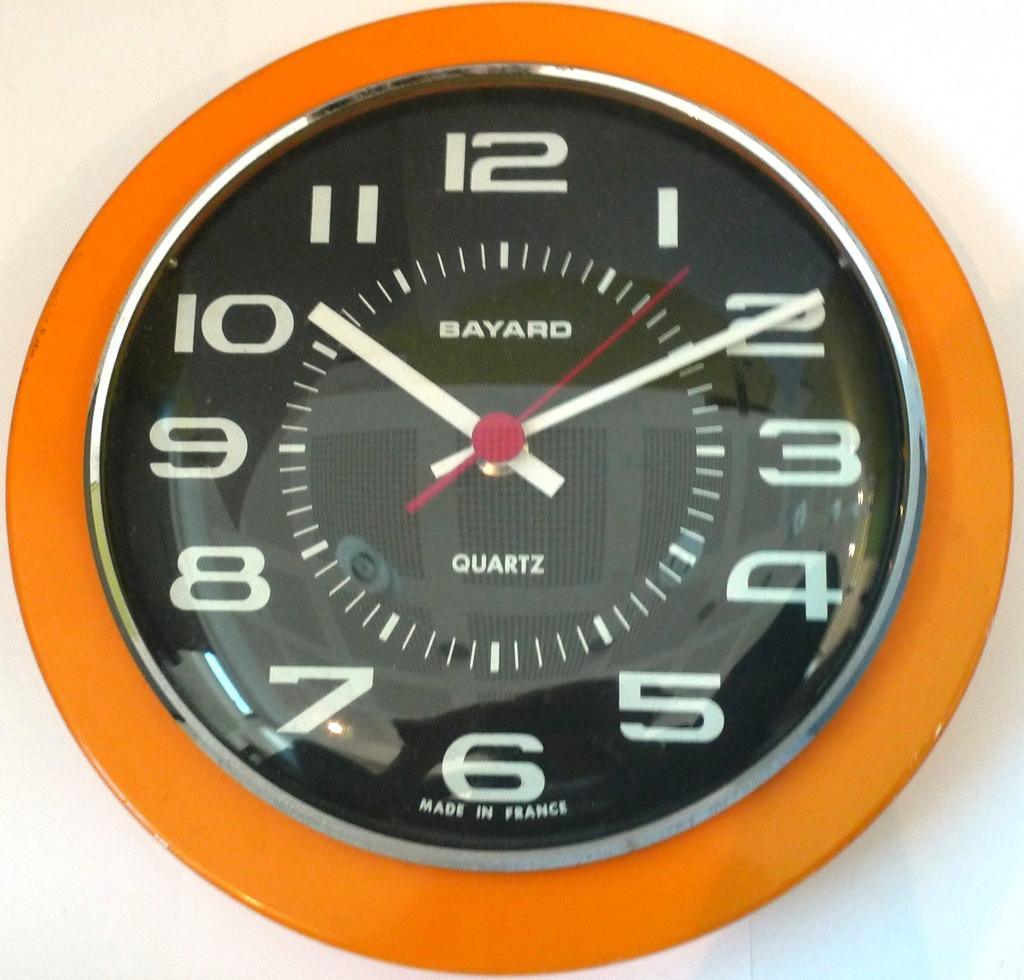<image>
Describe the image concisely. The bayard wall clock made from quartz hanging on the wall. 